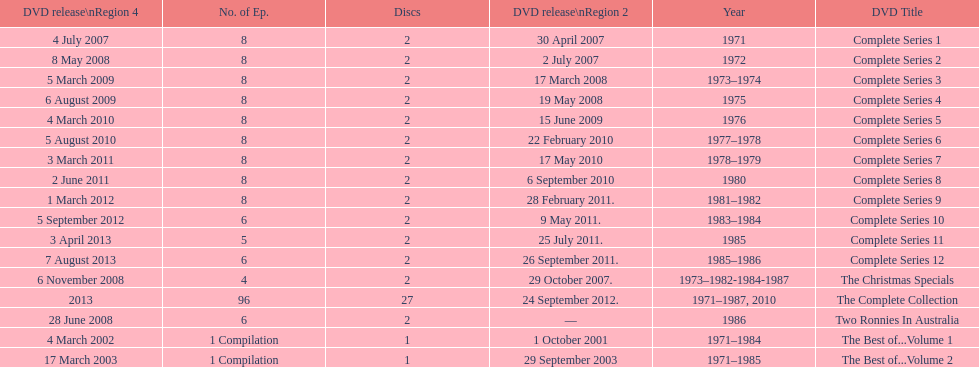What comes immediately after complete series 11? Complete Series 12. 